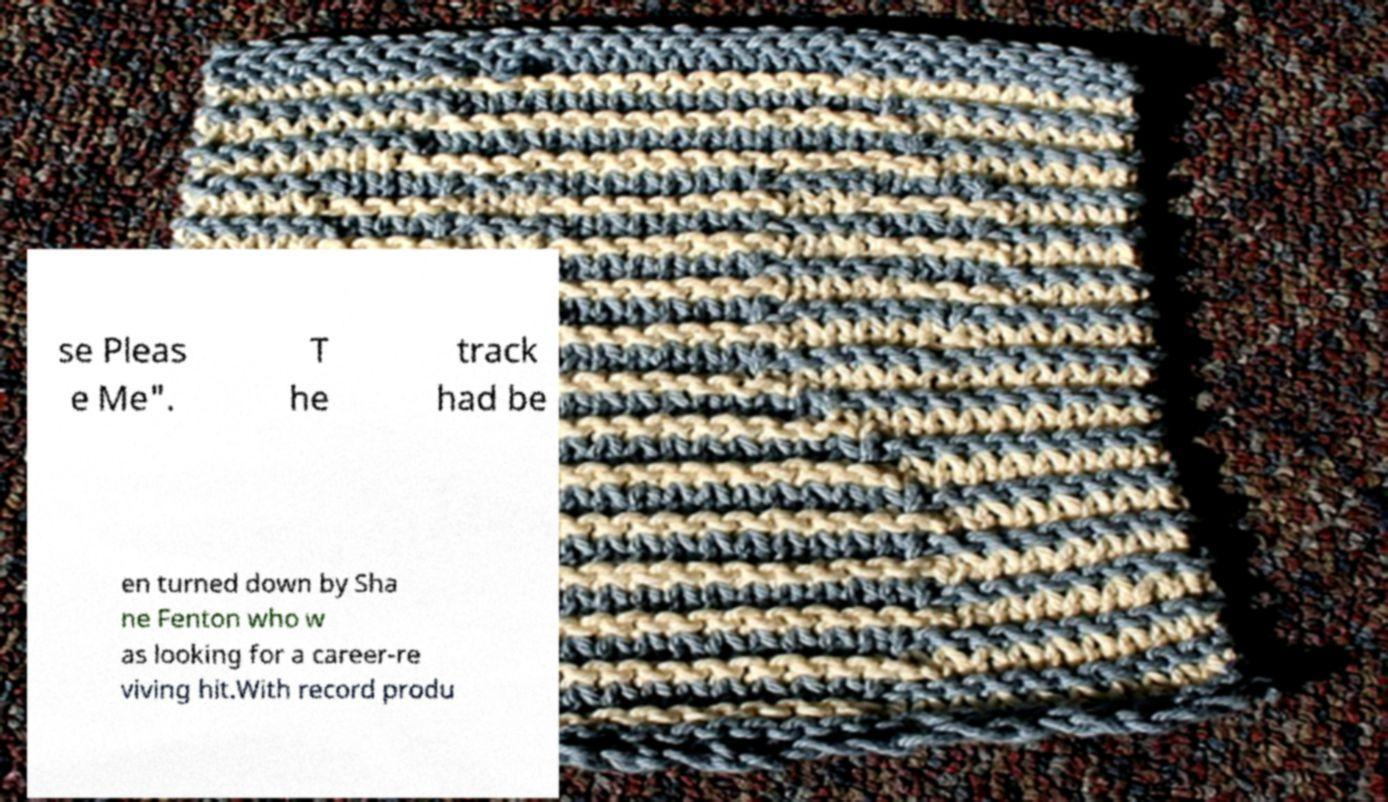I need the written content from this picture converted into text. Can you do that? se Pleas e Me". T he track had be en turned down by Sha ne Fenton who w as looking for a career-re viving hit.With record produ 